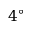<formula> <loc_0><loc_0><loc_500><loc_500>4 ^ { \circ }</formula> 